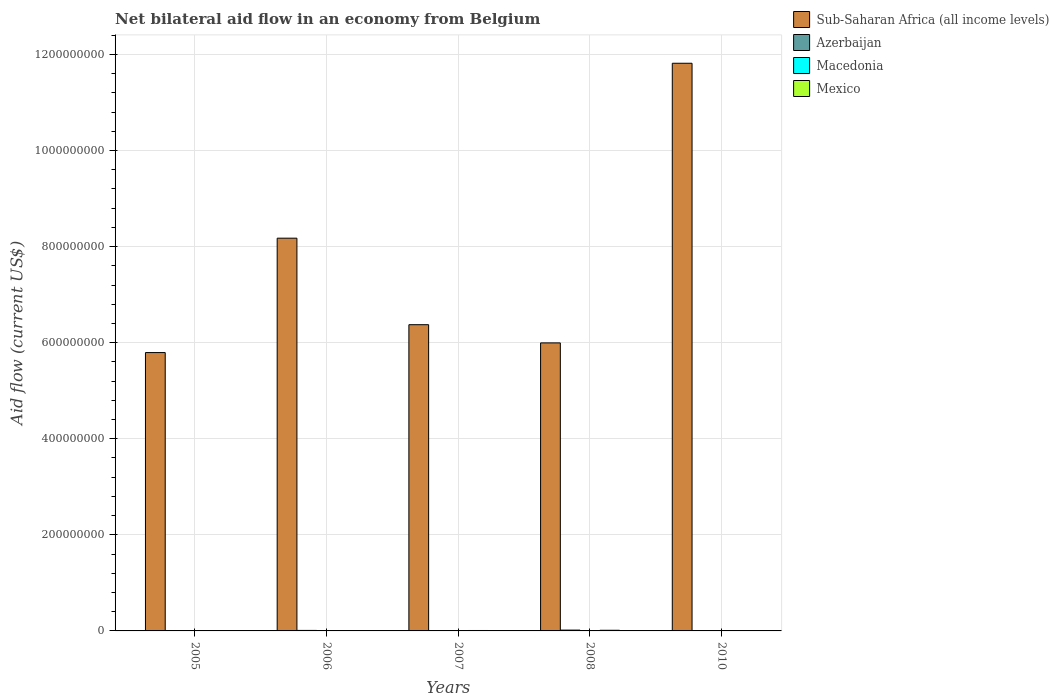How many different coloured bars are there?
Offer a very short reply. 4. How many groups of bars are there?
Make the answer very short. 5. Are the number of bars per tick equal to the number of legend labels?
Your answer should be very brief. Yes. How many bars are there on the 2nd tick from the left?
Keep it short and to the point. 4. How many bars are there on the 3rd tick from the right?
Offer a terse response. 4. What is the label of the 4th group of bars from the left?
Offer a terse response. 2008. In how many cases, is the number of bars for a given year not equal to the number of legend labels?
Offer a very short reply. 0. Across all years, what is the maximum net bilateral aid flow in Macedonia?
Make the answer very short. 3.60e+05. In which year was the net bilateral aid flow in Macedonia minimum?
Your answer should be compact. 2010. What is the total net bilateral aid flow in Mexico in the graph?
Offer a terse response. 3.67e+06. What is the difference between the net bilateral aid flow in Azerbaijan in 2006 and that in 2010?
Offer a terse response. 1.06e+06. What is the difference between the net bilateral aid flow in Sub-Saharan Africa (all income levels) in 2007 and the net bilateral aid flow in Azerbaijan in 2006?
Provide a short and direct response. 6.36e+08. What is the average net bilateral aid flow in Sub-Saharan Africa (all income levels) per year?
Your answer should be compact. 7.63e+08. In the year 2008, what is the difference between the net bilateral aid flow in Mexico and net bilateral aid flow in Sub-Saharan Africa (all income levels)?
Your response must be concise. -5.98e+08. What is the ratio of the net bilateral aid flow in Sub-Saharan Africa (all income levels) in 2005 to that in 2007?
Keep it short and to the point. 0.91. What is the difference between the highest and the second highest net bilateral aid flow in Sub-Saharan Africa (all income levels)?
Your answer should be very brief. 3.64e+08. What is the difference between the highest and the lowest net bilateral aid flow in Sub-Saharan Africa (all income levels)?
Make the answer very short. 6.02e+08. In how many years, is the net bilateral aid flow in Mexico greater than the average net bilateral aid flow in Mexico taken over all years?
Provide a succinct answer. 2. What does the 3rd bar from the left in 2005 represents?
Ensure brevity in your answer.  Macedonia. Is it the case that in every year, the sum of the net bilateral aid flow in Mexico and net bilateral aid flow in Macedonia is greater than the net bilateral aid flow in Sub-Saharan Africa (all income levels)?
Give a very brief answer. No. Are all the bars in the graph horizontal?
Your response must be concise. No. How many years are there in the graph?
Provide a succinct answer. 5. What is the difference between two consecutive major ticks on the Y-axis?
Offer a terse response. 2.00e+08. Does the graph contain grids?
Ensure brevity in your answer.  Yes. How many legend labels are there?
Give a very brief answer. 4. What is the title of the graph?
Ensure brevity in your answer.  Net bilateral aid flow in an economy from Belgium. Does "Moldova" appear as one of the legend labels in the graph?
Provide a short and direct response. No. What is the label or title of the X-axis?
Offer a very short reply. Years. What is the label or title of the Y-axis?
Give a very brief answer. Aid flow (current US$). What is the Aid flow (current US$) of Sub-Saharan Africa (all income levels) in 2005?
Your response must be concise. 5.79e+08. What is the Aid flow (current US$) of Macedonia in 2005?
Provide a short and direct response. 3.60e+05. What is the Aid flow (current US$) of Mexico in 2005?
Your answer should be very brief. 5.40e+05. What is the Aid flow (current US$) in Sub-Saharan Africa (all income levels) in 2006?
Provide a short and direct response. 8.18e+08. What is the Aid flow (current US$) in Azerbaijan in 2006?
Provide a succinct answer. 1.07e+06. What is the Aid flow (current US$) of Mexico in 2006?
Provide a short and direct response. 2.90e+05. What is the Aid flow (current US$) of Sub-Saharan Africa (all income levels) in 2007?
Your response must be concise. 6.38e+08. What is the Aid flow (current US$) of Sub-Saharan Africa (all income levels) in 2008?
Your response must be concise. 6.00e+08. What is the Aid flow (current US$) in Azerbaijan in 2008?
Make the answer very short. 1.71e+06. What is the Aid flow (current US$) in Mexico in 2008?
Make the answer very short. 1.36e+06. What is the Aid flow (current US$) of Sub-Saharan Africa (all income levels) in 2010?
Make the answer very short. 1.18e+09. What is the Aid flow (current US$) in Mexico in 2010?
Keep it short and to the point. 5.80e+05. Across all years, what is the maximum Aid flow (current US$) in Sub-Saharan Africa (all income levels)?
Your answer should be compact. 1.18e+09. Across all years, what is the maximum Aid flow (current US$) of Azerbaijan?
Give a very brief answer. 1.71e+06. Across all years, what is the maximum Aid flow (current US$) in Mexico?
Your answer should be compact. 1.36e+06. Across all years, what is the minimum Aid flow (current US$) of Sub-Saharan Africa (all income levels)?
Give a very brief answer. 5.79e+08. Across all years, what is the minimum Aid flow (current US$) of Azerbaijan?
Your answer should be very brief. 10000. Across all years, what is the minimum Aid flow (current US$) in Macedonia?
Offer a very short reply. 5.00e+04. Across all years, what is the minimum Aid flow (current US$) of Mexico?
Provide a succinct answer. 2.90e+05. What is the total Aid flow (current US$) of Sub-Saharan Africa (all income levels) in the graph?
Provide a succinct answer. 3.82e+09. What is the total Aid flow (current US$) of Azerbaijan in the graph?
Make the answer very short. 2.88e+06. What is the total Aid flow (current US$) in Macedonia in the graph?
Your response must be concise. 8.60e+05. What is the total Aid flow (current US$) of Mexico in the graph?
Give a very brief answer. 3.67e+06. What is the difference between the Aid flow (current US$) in Sub-Saharan Africa (all income levels) in 2005 and that in 2006?
Your answer should be compact. -2.38e+08. What is the difference between the Aid flow (current US$) in Azerbaijan in 2005 and that in 2006?
Offer a very short reply. -1.00e+06. What is the difference between the Aid flow (current US$) in Sub-Saharan Africa (all income levels) in 2005 and that in 2007?
Give a very brief answer. -5.80e+07. What is the difference between the Aid flow (current US$) of Mexico in 2005 and that in 2007?
Ensure brevity in your answer.  -3.60e+05. What is the difference between the Aid flow (current US$) of Sub-Saharan Africa (all income levels) in 2005 and that in 2008?
Ensure brevity in your answer.  -2.01e+07. What is the difference between the Aid flow (current US$) in Azerbaijan in 2005 and that in 2008?
Provide a short and direct response. -1.64e+06. What is the difference between the Aid flow (current US$) of Mexico in 2005 and that in 2008?
Keep it short and to the point. -8.20e+05. What is the difference between the Aid flow (current US$) of Sub-Saharan Africa (all income levels) in 2005 and that in 2010?
Offer a very short reply. -6.02e+08. What is the difference between the Aid flow (current US$) in Azerbaijan in 2005 and that in 2010?
Provide a short and direct response. 6.00e+04. What is the difference between the Aid flow (current US$) in Mexico in 2005 and that in 2010?
Your answer should be very brief. -4.00e+04. What is the difference between the Aid flow (current US$) of Sub-Saharan Africa (all income levels) in 2006 and that in 2007?
Your answer should be very brief. 1.80e+08. What is the difference between the Aid flow (current US$) of Azerbaijan in 2006 and that in 2007?
Provide a succinct answer. 1.05e+06. What is the difference between the Aid flow (current US$) of Macedonia in 2006 and that in 2007?
Make the answer very short. -3.00e+04. What is the difference between the Aid flow (current US$) in Mexico in 2006 and that in 2007?
Give a very brief answer. -6.10e+05. What is the difference between the Aid flow (current US$) of Sub-Saharan Africa (all income levels) in 2006 and that in 2008?
Keep it short and to the point. 2.18e+08. What is the difference between the Aid flow (current US$) in Azerbaijan in 2006 and that in 2008?
Make the answer very short. -6.40e+05. What is the difference between the Aid flow (current US$) in Mexico in 2006 and that in 2008?
Make the answer very short. -1.07e+06. What is the difference between the Aid flow (current US$) in Sub-Saharan Africa (all income levels) in 2006 and that in 2010?
Ensure brevity in your answer.  -3.64e+08. What is the difference between the Aid flow (current US$) of Azerbaijan in 2006 and that in 2010?
Make the answer very short. 1.06e+06. What is the difference between the Aid flow (current US$) in Sub-Saharan Africa (all income levels) in 2007 and that in 2008?
Provide a short and direct response. 3.79e+07. What is the difference between the Aid flow (current US$) in Azerbaijan in 2007 and that in 2008?
Provide a succinct answer. -1.69e+06. What is the difference between the Aid flow (current US$) of Macedonia in 2007 and that in 2008?
Provide a short and direct response. -6.00e+04. What is the difference between the Aid flow (current US$) of Mexico in 2007 and that in 2008?
Make the answer very short. -4.60e+05. What is the difference between the Aid flow (current US$) of Sub-Saharan Africa (all income levels) in 2007 and that in 2010?
Give a very brief answer. -5.44e+08. What is the difference between the Aid flow (current US$) of Mexico in 2007 and that in 2010?
Give a very brief answer. 3.20e+05. What is the difference between the Aid flow (current US$) in Sub-Saharan Africa (all income levels) in 2008 and that in 2010?
Your answer should be compact. -5.82e+08. What is the difference between the Aid flow (current US$) in Azerbaijan in 2008 and that in 2010?
Your response must be concise. 1.70e+06. What is the difference between the Aid flow (current US$) of Macedonia in 2008 and that in 2010?
Your response must be concise. 1.50e+05. What is the difference between the Aid flow (current US$) in Mexico in 2008 and that in 2010?
Your response must be concise. 7.80e+05. What is the difference between the Aid flow (current US$) in Sub-Saharan Africa (all income levels) in 2005 and the Aid flow (current US$) in Azerbaijan in 2006?
Your answer should be very brief. 5.78e+08. What is the difference between the Aid flow (current US$) of Sub-Saharan Africa (all income levels) in 2005 and the Aid flow (current US$) of Macedonia in 2006?
Provide a short and direct response. 5.79e+08. What is the difference between the Aid flow (current US$) in Sub-Saharan Africa (all income levels) in 2005 and the Aid flow (current US$) in Mexico in 2006?
Offer a very short reply. 5.79e+08. What is the difference between the Aid flow (current US$) of Macedonia in 2005 and the Aid flow (current US$) of Mexico in 2006?
Offer a very short reply. 7.00e+04. What is the difference between the Aid flow (current US$) of Sub-Saharan Africa (all income levels) in 2005 and the Aid flow (current US$) of Azerbaijan in 2007?
Offer a very short reply. 5.79e+08. What is the difference between the Aid flow (current US$) in Sub-Saharan Africa (all income levels) in 2005 and the Aid flow (current US$) in Macedonia in 2007?
Provide a succinct answer. 5.79e+08. What is the difference between the Aid flow (current US$) of Sub-Saharan Africa (all income levels) in 2005 and the Aid flow (current US$) of Mexico in 2007?
Provide a succinct answer. 5.79e+08. What is the difference between the Aid flow (current US$) of Azerbaijan in 2005 and the Aid flow (current US$) of Mexico in 2007?
Keep it short and to the point. -8.30e+05. What is the difference between the Aid flow (current US$) in Macedonia in 2005 and the Aid flow (current US$) in Mexico in 2007?
Offer a terse response. -5.40e+05. What is the difference between the Aid flow (current US$) of Sub-Saharan Africa (all income levels) in 2005 and the Aid flow (current US$) of Azerbaijan in 2008?
Provide a succinct answer. 5.78e+08. What is the difference between the Aid flow (current US$) in Sub-Saharan Africa (all income levels) in 2005 and the Aid flow (current US$) in Macedonia in 2008?
Your answer should be compact. 5.79e+08. What is the difference between the Aid flow (current US$) of Sub-Saharan Africa (all income levels) in 2005 and the Aid flow (current US$) of Mexico in 2008?
Your answer should be compact. 5.78e+08. What is the difference between the Aid flow (current US$) in Azerbaijan in 2005 and the Aid flow (current US$) in Mexico in 2008?
Offer a very short reply. -1.29e+06. What is the difference between the Aid flow (current US$) of Macedonia in 2005 and the Aid flow (current US$) of Mexico in 2008?
Offer a terse response. -1.00e+06. What is the difference between the Aid flow (current US$) in Sub-Saharan Africa (all income levels) in 2005 and the Aid flow (current US$) in Azerbaijan in 2010?
Your answer should be compact. 5.79e+08. What is the difference between the Aid flow (current US$) of Sub-Saharan Africa (all income levels) in 2005 and the Aid flow (current US$) of Macedonia in 2010?
Ensure brevity in your answer.  5.79e+08. What is the difference between the Aid flow (current US$) of Sub-Saharan Africa (all income levels) in 2005 and the Aid flow (current US$) of Mexico in 2010?
Ensure brevity in your answer.  5.79e+08. What is the difference between the Aid flow (current US$) of Azerbaijan in 2005 and the Aid flow (current US$) of Macedonia in 2010?
Make the answer very short. 2.00e+04. What is the difference between the Aid flow (current US$) of Azerbaijan in 2005 and the Aid flow (current US$) of Mexico in 2010?
Give a very brief answer. -5.10e+05. What is the difference between the Aid flow (current US$) of Macedonia in 2005 and the Aid flow (current US$) of Mexico in 2010?
Provide a short and direct response. -2.20e+05. What is the difference between the Aid flow (current US$) in Sub-Saharan Africa (all income levels) in 2006 and the Aid flow (current US$) in Azerbaijan in 2007?
Your answer should be compact. 8.18e+08. What is the difference between the Aid flow (current US$) in Sub-Saharan Africa (all income levels) in 2006 and the Aid flow (current US$) in Macedonia in 2007?
Provide a short and direct response. 8.17e+08. What is the difference between the Aid flow (current US$) of Sub-Saharan Africa (all income levels) in 2006 and the Aid flow (current US$) of Mexico in 2007?
Your answer should be compact. 8.17e+08. What is the difference between the Aid flow (current US$) of Azerbaijan in 2006 and the Aid flow (current US$) of Macedonia in 2007?
Keep it short and to the point. 9.30e+05. What is the difference between the Aid flow (current US$) in Macedonia in 2006 and the Aid flow (current US$) in Mexico in 2007?
Give a very brief answer. -7.90e+05. What is the difference between the Aid flow (current US$) of Sub-Saharan Africa (all income levels) in 2006 and the Aid flow (current US$) of Azerbaijan in 2008?
Provide a short and direct response. 8.16e+08. What is the difference between the Aid flow (current US$) in Sub-Saharan Africa (all income levels) in 2006 and the Aid flow (current US$) in Macedonia in 2008?
Keep it short and to the point. 8.17e+08. What is the difference between the Aid flow (current US$) of Sub-Saharan Africa (all income levels) in 2006 and the Aid flow (current US$) of Mexico in 2008?
Provide a succinct answer. 8.16e+08. What is the difference between the Aid flow (current US$) of Azerbaijan in 2006 and the Aid flow (current US$) of Macedonia in 2008?
Offer a terse response. 8.70e+05. What is the difference between the Aid flow (current US$) of Macedonia in 2006 and the Aid flow (current US$) of Mexico in 2008?
Your answer should be compact. -1.25e+06. What is the difference between the Aid flow (current US$) in Sub-Saharan Africa (all income levels) in 2006 and the Aid flow (current US$) in Azerbaijan in 2010?
Provide a short and direct response. 8.18e+08. What is the difference between the Aid flow (current US$) in Sub-Saharan Africa (all income levels) in 2006 and the Aid flow (current US$) in Macedonia in 2010?
Provide a short and direct response. 8.18e+08. What is the difference between the Aid flow (current US$) in Sub-Saharan Africa (all income levels) in 2006 and the Aid flow (current US$) in Mexico in 2010?
Your answer should be very brief. 8.17e+08. What is the difference between the Aid flow (current US$) of Azerbaijan in 2006 and the Aid flow (current US$) of Macedonia in 2010?
Keep it short and to the point. 1.02e+06. What is the difference between the Aid flow (current US$) of Macedonia in 2006 and the Aid flow (current US$) of Mexico in 2010?
Offer a terse response. -4.70e+05. What is the difference between the Aid flow (current US$) in Sub-Saharan Africa (all income levels) in 2007 and the Aid flow (current US$) in Azerbaijan in 2008?
Keep it short and to the point. 6.36e+08. What is the difference between the Aid flow (current US$) in Sub-Saharan Africa (all income levels) in 2007 and the Aid flow (current US$) in Macedonia in 2008?
Offer a very short reply. 6.37e+08. What is the difference between the Aid flow (current US$) of Sub-Saharan Africa (all income levels) in 2007 and the Aid flow (current US$) of Mexico in 2008?
Offer a terse response. 6.36e+08. What is the difference between the Aid flow (current US$) in Azerbaijan in 2007 and the Aid flow (current US$) in Mexico in 2008?
Your answer should be compact. -1.34e+06. What is the difference between the Aid flow (current US$) in Macedonia in 2007 and the Aid flow (current US$) in Mexico in 2008?
Ensure brevity in your answer.  -1.22e+06. What is the difference between the Aid flow (current US$) of Sub-Saharan Africa (all income levels) in 2007 and the Aid flow (current US$) of Azerbaijan in 2010?
Give a very brief answer. 6.38e+08. What is the difference between the Aid flow (current US$) of Sub-Saharan Africa (all income levels) in 2007 and the Aid flow (current US$) of Macedonia in 2010?
Provide a succinct answer. 6.37e+08. What is the difference between the Aid flow (current US$) in Sub-Saharan Africa (all income levels) in 2007 and the Aid flow (current US$) in Mexico in 2010?
Provide a succinct answer. 6.37e+08. What is the difference between the Aid flow (current US$) in Azerbaijan in 2007 and the Aid flow (current US$) in Mexico in 2010?
Ensure brevity in your answer.  -5.60e+05. What is the difference between the Aid flow (current US$) in Macedonia in 2007 and the Aid flow (current US$) in Mexico in 2010?
Your response must be concise. -4.40e+05. What is the difference between the Aid flow (current US$) of Sub-Saharan Africa (all income levels) in 2008 and the Aid flow (current US$) of Azerbaijan in 2010?
Provide a succinct answer. 6.00e+08. What is the difference between the Aid flow (current US$) of Sub-Saharan Africa (all income levels) in 2008 and the Aid flow (current US$) of Macedonia in 2010?
Offer a very short reply. 6.00e+08. What is the difference between the Aid flow (current US$) in Sub-Saharan Africa (all income levels) in 2008 and the Aid flow (current US$) in Mexico in 2010?
Provide a succinct answer. 5.99e+08. What is the difference between the Aid flow (current US$) of Azerbaijan in 2008 and the Aid flow (current US$) of Macedonia in 2010?
Your answer should be very brief. 1.66e+06. What is the difference between the Aid flow (current US$) of Azerbaijan in 2008 and the Aid flow (current US$) of Mexico in 2010?
Provide a succinct answer. 1.13e+06. What is the difference between the Aid flow (current US$) of Macedonia in 2008 and the Aid flow (current US$) of Mexico in 2010?
Keep it short and to the point. -3.80e+05. What is the average Aid flow (current US$) of Sub-Saharan Africa (all income levels) per year?
Ensure brevity in your answer.  7.63e+08. What is the average Aid flow (current US$) in Azerbaijan per year?
Make the answer very short. 5.76e+05. What is the average Aid flow (current US$) of Macedonia per year?
Keep it short and to the point. 1.72e+05. What is the average Aid flow (current US$) in Mexico per year?
Give a very brief answer. 7.34e+05. In the year 2005, what is the difference between the Aid flow (current US$) in Sub-Saharan Africa (all income levels) and Aid flow (current US$) in Azerbaijan?
Offer a very short reply. 5.79e+08. In the year 2005, what is the difference between the Aid flow (current US$) in Sub-Saharan Africa (all income levels) and Aid flow (current US$) in Macedonia?
Offer a terse response. 5.79e+08. In the year 2005, what is the difference between the Aid flow (current US$) in Sub-Saharan Africa (all income levels) and Aid flow (current US$) in Mexico?
Provide a short and direct response. 5.79e+08. In the year 2005, what is the difference between the Aid flow (current US$) of Azerbaijan and Aid flow (current US$) of Mexico?
Your response must be concise. -4.70e+05. In the year 2006, what is the difference between the Aid flow (current US$) in Sub-Saharan Africa (all income levels) and Aid flow (current US$) in Azerbaijan?
Offer a very short reply. 8.17e+08. In the year 2006, what is the difference between the Aid flow (current US$) of Sub-Saharan Africa (all income levels) and Aid flow (current US$) of Macedonia?
Make the answer very short. 8.17e+08. In the year 2006, what is the difference between the Aid flow (current US$) in Sub-Saharan Africa (all income levels) and Aid flow (current US$) in Mexico?
Your response must be concise. 8.17e+08. In the year 2006, what is the difference between the Aid flow (current US$) of Azerbaijan and Aid flow (current US$) of Macedonia?
Keep it short and to the point. 9.60e+05. In the year 2006, what is the difference between the Aid flow (current US$) in Azerbaijan and Aid flow (current US$) in Mexico?
Make the answer very short. 7.80e+05. In the year 2007, what is the difference between the Aid flow (current US$) of Sub-Saharan Africa (all income levels) and Aid flow (current US$) of Azerbaijan?
Give a very brief answer. 6.37e+08. In the year 2007, what is the difference between the Aid flow (current US$) of Sub-Saharan Africa (all income levels) and Aid flow (current US$) of Macedonia?
Keep it short and to the point. 6.37e+08. In the year 2007, what is the difference between the Aid flow (current US$) in Sub-Saharan Africa (all income levels) and Aid flow (current US$) in Mexico?
Make the answer very short. 6.37e+08. In the year 2007, what is the difference between the Aid flow (current US$) in Azerbaijan and Aid flow (current US$) in Mexico?
Your answer should be compact. -8.80e+05. In the year 2007, what is the difference between the Aid flow (current US$) of Macedonia and Aid flow (current US$) of Mexico?
Offer a terse response. -7.60e+05. In the year 2008, what is the difference between the Aid flow (current US$) in Sub-Saharan Africa (all income levels) and Aid flow (current US$) in Azerbaijan?
Make the answer very short. 5.98e+08. In the year 2008, what is the difference between the Aid flow (current US$) of Sub-Saharan Africa (all income levels) and Aid flow (current US$) of Macedonia?
Provide a short and direct response. 5.99e+08. In the year 2008, what is the difference between the Aid flow (current US$) in Sub-Saharan Africa (all income levels) and Aid flow (current US$) in Mexico?
Ensure brevity in your answer.  5.98e+08. In the year 2008, what is the difference between the Aid flow (current US$) of Azerbaijan and Aid flow (current US$) of Macedonia?
Make the answer very short. 1.51e+06. In the year 2008, what is the difference between the Aid flow (current US$) of Macedonia and Aid flow (current US$) of Mexico?
Offer a very short reply. -1.16e+06. In the year 2010, what is the difference between the Aid flow (current US$) in Sub-Saharan Africa (all income levels) and Aid flow (current US$) in Azerbaijan?
Offer a terse response. 1.18e+09. In the year 2010, what is the difference between the Aid flow (current US$) in Sub-Saharan Africa (all income levels) and Aid flow (current US$) in Macedonia?
Offer a very short reply. 1.18e+09. In the year 2010, what is the difference between the Aid flow (current US$) in Sub-Saharan Africa (all income levels) and Aid flow (current US$) in Mexico?
Your answer should be very brief. 1.18e+09. In the year 2010, what is the difference between the Aid flow (current US$) of Azerbaijan and Aid flow (current US$) of Mexico?
Make the answer very short. -5.70e+05. In the year 2010, what is the difference between the Aid flow (current US$) of Macedonia and Aid flow (current US$) of Mexico?
Keep it short and to the point. -5.30e+05. What is the ratio of the Aid flow (current US$) of Sub-Saharan Africa (all income levels) in 2005 to that in 2006?
Offer a terse response. 0.71. What is the ratio of the Aid flow (current US$) in Azerbaijan in 2005 to that in 2006?
Offer a very short reply. 0.07. What is the ratio of the Aid flow (current US$) of Macedonia in 2005 to that in 2006?
Keep it short and to the point. 3.27. What is the ratio of the Aid flow (current US$) in Mexico in 2005 to that in 2006?
Make the answer very short. 1.86. What is the ratio of the Aid flow (current US$) in Sub-Saharan Africa (all income levels) in 2005 to that in 2007?
Make the answer very short. 0.91. What is the ratio of the Aid flow (current US$) of Azerbaijan in 2005 to that in 2007?
Your response must be concise. 3.5. What is the ratio of the Aid flow (current US$) of Macedonia in 2005 to that in 2007?
Your answer should be very brief. 2.57. What is the ratio of the Aid flow (current US$) in Sub-Saharan Africa (all income levels) in 2005 to that in 2008?
Provide a succinct answer. 0.97. What is the ratio of the Aid flow (current US$) of Azerbaijan in 2005 to that in 2008?
Provide a short and direct response. 0.04. What is the ratio of the Aid flow (current US$) in Mexico in 2005 to that in 2008?
Your response must be concise. 0.4. What is the ratio of the Aid flow (current US$) of Sub-Saharan Africa (all income levels) in 2005 to that in 2010?
Your answer should be compact. 0.49. What is the ratio of the Aid flow (current US$) in Azerbaijan in 2005 to that in 2010?
Your response must be concise. 7. What is the ratio of the Aid flow (current US$) in Mexico in 2005 to that in 2010?
Your response must be concise. 0.93. What is the ratio of the Aid flow (current US$) of Sub-Saharan Africa (all income levels) in 2006 to that in 2007?
Give a very brief answer. 1.28. What is the ratio of the Aid flow (current US$) of Azerbaijan in 2006 to that in 2007?
Give a very brief answer. 53.5. What is the ratio of the Aid flow (current US$) of Macedonia in 2006 to that in 2007?
Give a very brief answer. 0.79. What is the ratio of the Aid flow (current US$) in Mexico in 2006 to that in 2007?
Your response must be concise. 0.32. What is the ratio of the Aid flow (current US$) in Sub-Saharan Africa (all income levels) in 2006 to that in 2008?
Your answer should be compact. 1.36. What is the ratio of the Aid flow (current US$) in Azerbaijan in 2006 to that in 2008?
Keep it short and to the point. 0.63. What is the ratio of the Aid flow (current US$) of Macedonia in 2006 to that in 2008?
Keep it short and to the point. 0.55. What is the ratio of the Aid flow (current US$) of Mexico in 2006 to that in 2008?
Offer a terse response. 0.21. What is the ratio of the Aid flow (current US$) of Sub-Saharan Africa (all income levels) in 2006 to that in 2010?
Your answer should be very brief. 0.69. What is the ratio of the Aid flow (current US$) in Azerbaijan in 2006 to that in 2010?
Provide a short and direct response. 107. What is the ratio of the Aid flow (current US$) in Macedonia in 2006 to that in 2010?
Keep it short and to the point. 2.2. What is the ratio of the Aid flow (current US$) of Mexico in 2006 to that in 2010?
Offer a very short reply. 0.5. What is the ratio of the Aid flow (current US$) of Sub-Saharan Africa (all income levels) in 2007 to that in 2008?
Your answer should be compact. 1.06. What is the ratio of the Aid flow (current US$) of Azerbaijan in 2007 to that in 2008?
Your response must be concise. 0.01. What is the ratio of the Aid flow (current US$) of Mexico in 2007 to that in 2008?
Provide a short and direct response. 0.66. What is the ratio of the Aid flow (current US$) in Sub-Saharan Africa (all income levels) in 2007 to that in 2010?
Ensure brevity in your answer.  0.54. What is the ratio of the Aid flow (current US$) in Azerbaijan in 2007 to that in 2010?
Make the answer very short. 2. What is the ratio of the Aid flow (current US$) of Mexico in 2007 to that in 2010?
Give a very brief answer. 1.55. What is the ratio of the Aid flow (current US$) in Sub-Saharan Africa (all income levels) in 2008 to that in 2010?
Keep it short and to the point. 0.51. What is the ratio of the Aid flow (current US$) in Azerbaijan in 2008 to that in 2010?
Provide a short and direct response. 171. What is the ratio of the Aid flow (current US$) in Macedonia in 2008 to that in 2010?
Ensure brevity in your answer.  4. What is the ratio of the Aid flow (current US$) in Mexico in 2008 to that in 2010?
Provide a succinct answer. 2.34. What is the difference between the highest and the second highest Aid flow (current US$) in Sub-Saharan Africa (all income levels)?
Offer a terse response. 3.64e+08. What is the difference between the highest and the second highest Aid flow (current US$) of Azerbaijan?
Offer a terse response. 6.40e+05. What is the difference between the highest and the second highest Aid flow (current US$) in Macedonia?
Your answer should be very brief. 1.60e+05. What is the difference between the highest and the second highest Aid flow (current US$) in Mexico?
Your answer should be very brief. 4.60e+05. What is the difference between the highest and the lowest Aid flow (current US$) in Sub-Saharan Africa (all income levels)?
Keep it short and to the point. 6.02e+08. What is the difference between the highest and the lowest Aid flow (current US$) in Azerbaijan?
Keep it short and to the point. 1.70e+06. What is the difference between the highest and the lowest Aid flow (current US$) in Mexico?
Keep it short and to the point. 1.07e+06. 